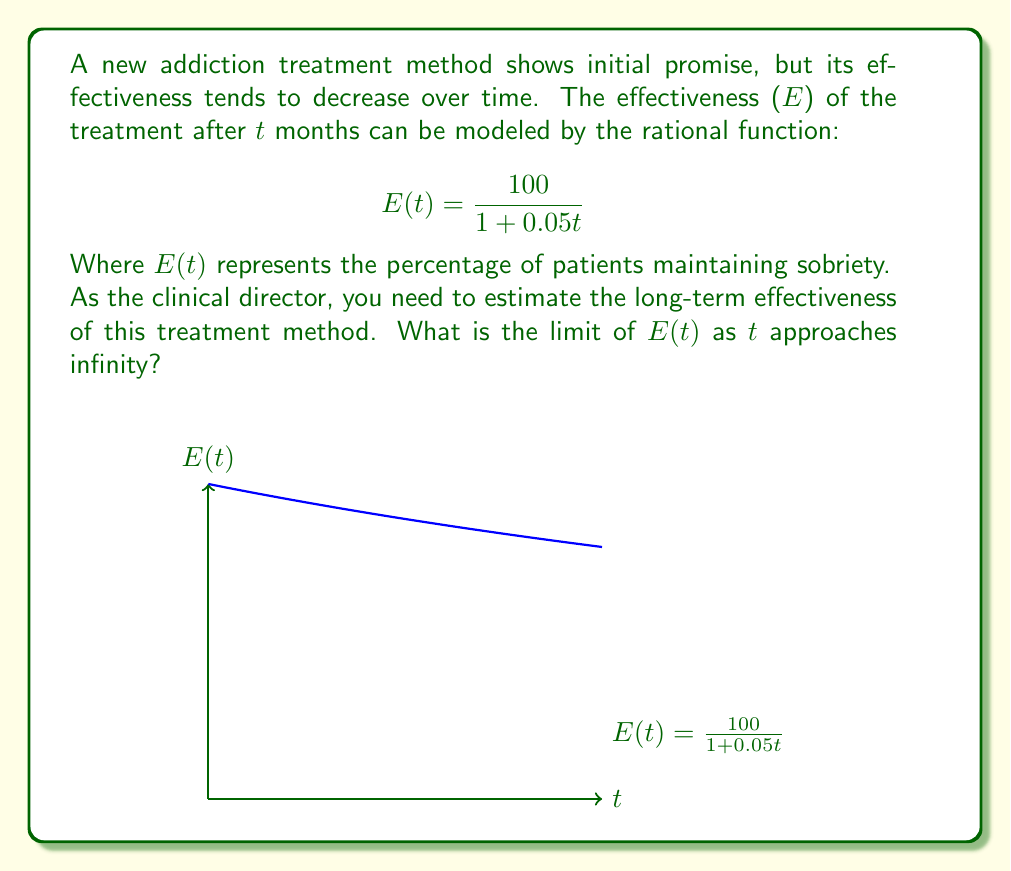Teach me how to tackle this problem. To find the limit of E(t) as t approaches infinity, we'll follow these steps:

1) First, let's examine the given function:
   $$E(t) = \frac{100}{1 + 0.05t}$$

2) To find the limit as t approaches infinity, we need to consider what happens to the numerator and denominator separately as t gets very large.

3) The numerator is a constant (100), so it doesn't change as t increases.

4) In the denominator, as t gets very large, 0.05t will dominate:
   $1 + 0.05t \approx 0.05t$ for very large t

5) So, for large t, our function behaves like:
   $$E(t) \approx \frac{100}{0.05t} = \frac{2000}{t}$$

6) Now, as t approaches infinity, this fraction approaches zero:
   $$\lim_{t \to \infty} \frac{2000}{t} = 0$$

7) Therefore, the limit of our original function as t approaches infinity is also 0:
   $$\lim_{t \to \infty} E(t) = \lim_{t \to \infty} \frac{100}{1 + 0.05t} = 0$$

This means that in the very long term, the effectiveness of the treatment approaches 0% as time goes to infinity.
Answer: 0% 